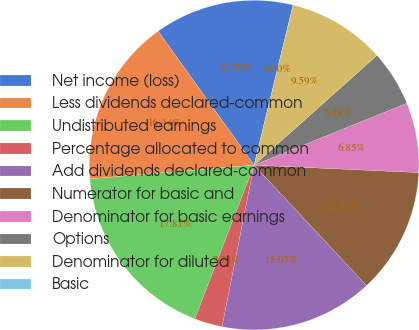<chart> <loc_0><loc_0><loc_500><loc_500><pie_chart><fcel>Net income (loss)<fcel>Less dividends declared-common<fcel>Undistributed earnings<fcel>Percentage allocated to common<fcel>Add dividends declared-common<fcel>Numerator for basic and<fcel>Denominator for basic earnings<fcel>Options<fcel>Denominator for diluted<fcel>Basic<nl><fcel>13.7%<fcel>16.44%<fcel>17.81%<fcel>2.74%<fcel>15.07%<fcel>12.33%<fcel>6.85%<fcel>5.48%<fcel>9.59%<fcel>0.0%<nl></chart> 